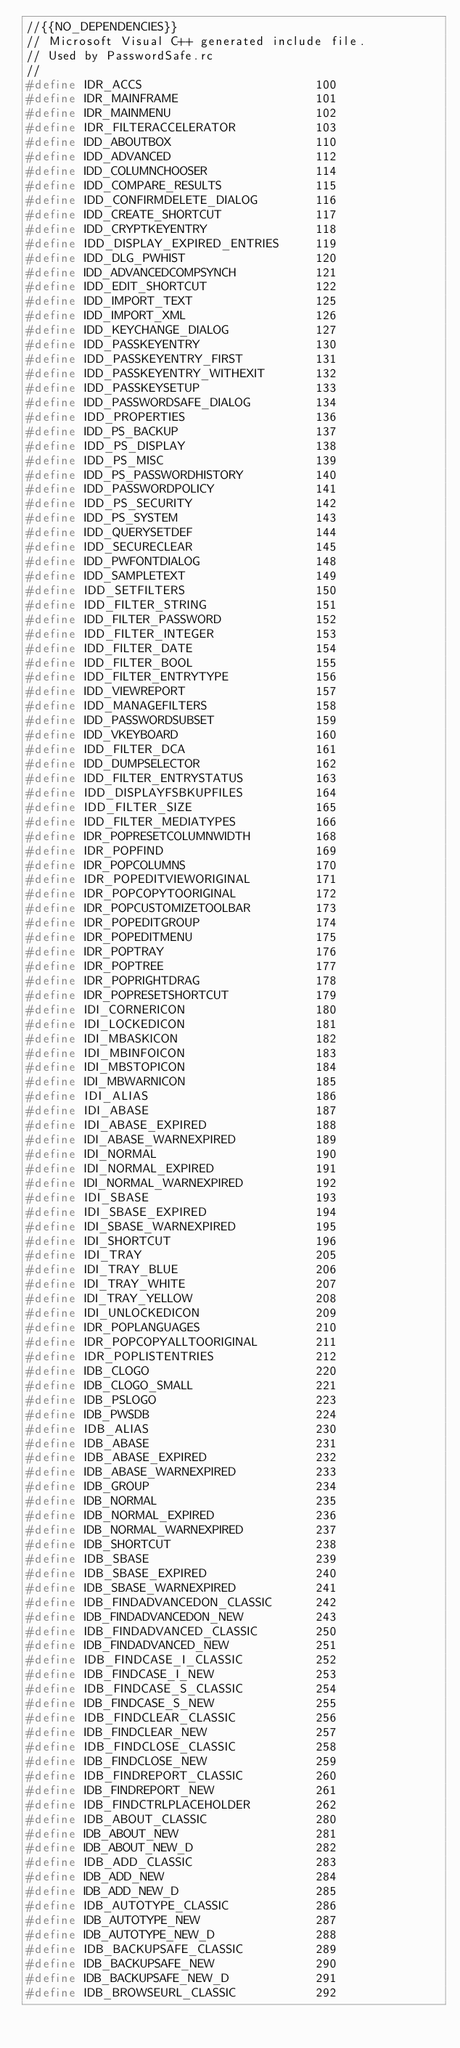Convert code to text. <code><loc_0><loc_0><loc_500><loc_500><_C_>//{{NO_DEPENDENCIES}}
// Microsoft Visual C++ generated include file.
// Used by PasswordSafe.rc
//
#define IDR_ACCS                        100
#define IDR_MAINFRAME                   101
#define IDR_MAINMENU                    102
#define IDR_FILTERACCELERATOR           103
#define IDD_ABOUTBOX                    110
#define IDD_ADVANCED                    112
#define IDD_COLUMNCHOOSER               114
#define IDD_COMPARE_RESULTS             115
#define IDD_CONFIRMDELETE_DIALOG        116
#define IDD_CREATE_SHORTCUT             117
#define IDD_CRYPTKEYENTRY               118
#define IDD_DISPLAY_EXPIRED_ENTRIES     119
#define IDD_DLG_PWHIST                  120
#define IDD_ADVANCEDCOMPSYNCH           121
#define IDD_EDIT_SHORTCUT               122
#define IDD_IMPORT_TEXT                 125
#define IDD_IMPORT_XML                  126
#define IDD_KEYCHANGE_DIALOG            127
#define IDD_PASSKEYENTRY                130
#define IDD_PASSKEYENTRY_FIRST          131
#define IDD_PASSKEYENTRY_WITHEXIT       132
#define IDD_PASSKEYSETUP                133
#define IDD_PASSWORDSAFE_DIALOG         134
#define IDD_PROPERTIES                  136
#define IDD_PS_BACKUP                   137
#define IDD_PS_DISPLAY                  138
#define IDD_PS_MISC                     139
#define IDD_PS_PASSWORDHISTORY          140
#define IDD_PASSWORDPOLICY              141
#define IDD_PS_SECURITY                 142
#define IDD_PS_SYSTEM                   143
#define IDD_QUERYSETDEF                 144
#define IDD_SECURECLEAR                 145
#define IDD_PWFONTDIALOG                148
#define IDD_SAMPLETEXT                  149
#define IDD_SETFILTERS                  150
#define IDD_FILTER_STRING               151
#define IDD_FILTER_PASSWORD             152
#define IDD_FILTER_INTEGER              153
#define IDD_FILTER_DATE                 154
#define IDD_FILTER_BOOL                 155
#define IDD_FILTER_ENTRYTYPE            156
#define IDD_VIEWREPORT                  157
#define IDD_MANAGEFILTERS               158
#define IDD_PASSWORDSUBSET              159
#define IDD_VKEYBOARD                   160
#define IDD_FILTER_DCA                  161
#define IDD_DUMPSELECTOR                162
#define IDD_FILTER_ENTRYSTATUS          163
#define IDD_DISPLAYFSBKUPFILES          164
#define IDD_FILTER_SIZE                 165
#define IDD_FILTER_MEDIATYPES           166
#define IDR_POPRESETCOLUMNWIDTH         168
#define IDR_POPFIND                     169
#define IDR_POPCOLUMNS                  170
#define IDR_POPEDITVIEWORIGINAL         171
#define IDR_POPCOPYTOORIGINAL           172
#define IDR_POPCUSTOMIZETOOLBAR         173
#define IDR_POPEDITGROUP                174
#define IDR_POPEDITMENU                 175
#define IDR_POPTRAY                     176
#define IDR_POPTREE                     177
#define IDR_POPRIGHTDRAG                178
#define IDR_POPRESETSHORTCUT            179
#define IDI_CORNERICON                  180
#define IDI_LOCKEDICON                  181
#define IDI_MBASKICON                   182
#define IDI_MBINFOICON                  183
#define IDI_MBSTOPICON                  184
#define IDI_MBWARNICON                  185
#define IDI_ALIAS                       186
#define IDI_ABASE                       187
#define IDI_ABASE_EXPIRED               188
#define IDI_ABASE_WARNEXPIRED           189
#define IDI_NORMAL                      190
#define IDI_NORMAL_EXPIRED              191
#define IDI_NORMAL_WARNEXPIRED          192
#define IDI_SBASE                       193
#define IDI_SBASE_EXPIRED               194
#define IDI_SBASE_WARNEXPIRED           195
#define IDI_SHORTCUT                    196
#define IDI_TRAY                        205
#define IDI_TRAY_BLUE                   206
#define IDI_TRAY_WHITE                  207
#define IDI_TRAY_YELLOW                 208
#define IDI_UNLOCKEDICON                209
#define IDR_POPLANGUAGES                210
#define IDR_POPCOPYALLTOORIGINAL        211
#define IDR_POPLISTENTRIES              212
#define IDB_CLOGO                       220
#define IDB_CLOGO_SMALL                 221
#define IDB_PSLOGO                      223
#define IDB_PWSDB                       224
#define IDB_ALIAS                       230
#define IDB_ABASE                       231
#define IDB_ABASE_EXPIRED               232
#define IDB_ABASE_WARNEXPIRED           233
#define IDB_GROUP                       234
#define IDB_NORMAL                      235
#define IDB_NORMAL_EXPIRED              236
#define IDB_NORMAL_WARNEXPIRED          237
#define IDB_SHORTCUT                    238
#define IDB_SBASE                       239
#define IDB_SBASE_EXPIRED               240
#define IDB_SBASE_WARNEXPIRED           241
#define IDB_FINDADVANCEDON_CLASSIC      242
#define IDB_FINDADVANCEDON_NEW          243
#define IDB_FINDADVANCED_CLASSIC        250
#define IDB_FINDADVANCED_NEW            251
#define IDB_FINDCASE_I_CLASSIC          252
#define IDB_FINDCASE_I_NEW              253
#define IDB_FINDCASE_S_CLASSIC          254
#define IDB_FINDCASE_S_NEW              255
#define IDB_FINDCLEAR_CLASSIC           256
#define IDB_FINDCLEAR_NEW               257
#define IDB_FINDCLOSE_CLASSIC           258
#define IDB_FINDCLOSE_NEW               259
#define IDB_FINDREPORT_CLASSIC          260
#define IDB_FINDREPORT_NEW              261
#define IDB_FINDCTRLPLACEHOLDER         262
#define IDB_ABOUT_CLASSIC               280
#define IDB_ABOUT_NEW                   281
#define IDB_ABOUT_NEW_D                 282
#define IDB_ADD_CLASSIC                 283
#define IDB_ADD_NEW                     284
#define IDB_ADD_NEW_D                   285
#define IDB_AUTOTYPE_CLASSIC            286
#define IDB_AUTOTYPE_NEW                287
#define IDB_AUTOTYPE_NEW_D              288
#define IDB_BACKUPSAFE_CLASSIC          289
#define IDB_BACKUPSAFE_NEW              290
#define IDB_BACKUPSAFE_NEW_D            291
#define IDB_BROWSEURL_CLASSIC           292</code> 